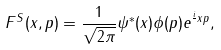<formula> <loc_0><loc_0><loc_500><loc_500>F ^ { S } ( x , p ) = \frac { 1 } { \sqrt { 2 \pi } } \psi ^ { * } ( x ) \phi ( p ) e ^ { \frac { i } { } x p } ,</formula> 